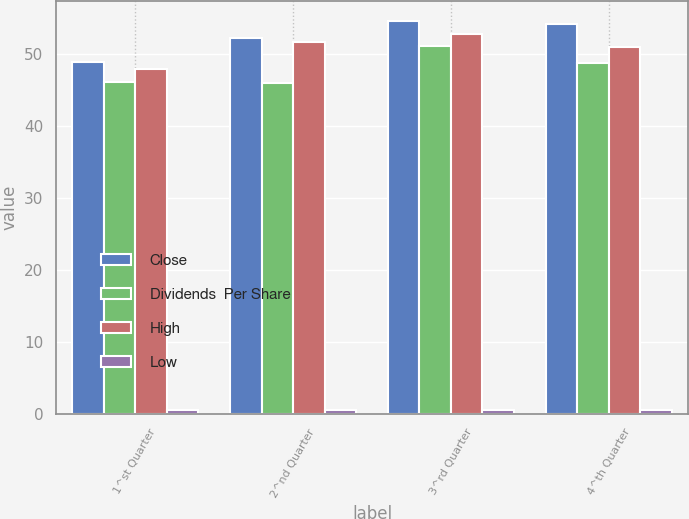<chart> <loc_0><loc_0><loc_500><loc_500><stacked_bar_chart><ecel><fcel>1^st Quarter<fcel>2^nd Quarter<fcel>3^rd Quarter<fcel>4^th Quarter<nl><fcel>Close<fcel>48.86<fcel>52.3<fcel>54.66<fcel>54.2<nl><fcel>Dividends  Per Share<fcel>46.15<fcel>45.95<fcel>51.19<fcel>48.73<nl><fcel>High<fcel>47.9<fcel>51.74<fcel>52.8<fcel>50.98<nl><fcel>Low<fcel>0.53<fcel>0.53<fcel>0.53<fcel>0.55<nl></chart> 